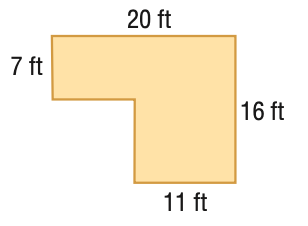Answer the mathemtical geometry problem and directly provide the correct option letter.
Question: Find the area of the figure. Round to the nearest tenth if necessary.
Choices: A: 81 B: 119.5 C: 239 D: 320 C 